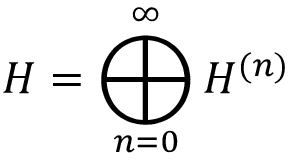<formula> <loc_0><loc_0><loc_500><loc_500>H = \bigoplus _ { n = 0 } ^ { \infty } H ^ { ( n ) }</formula> 